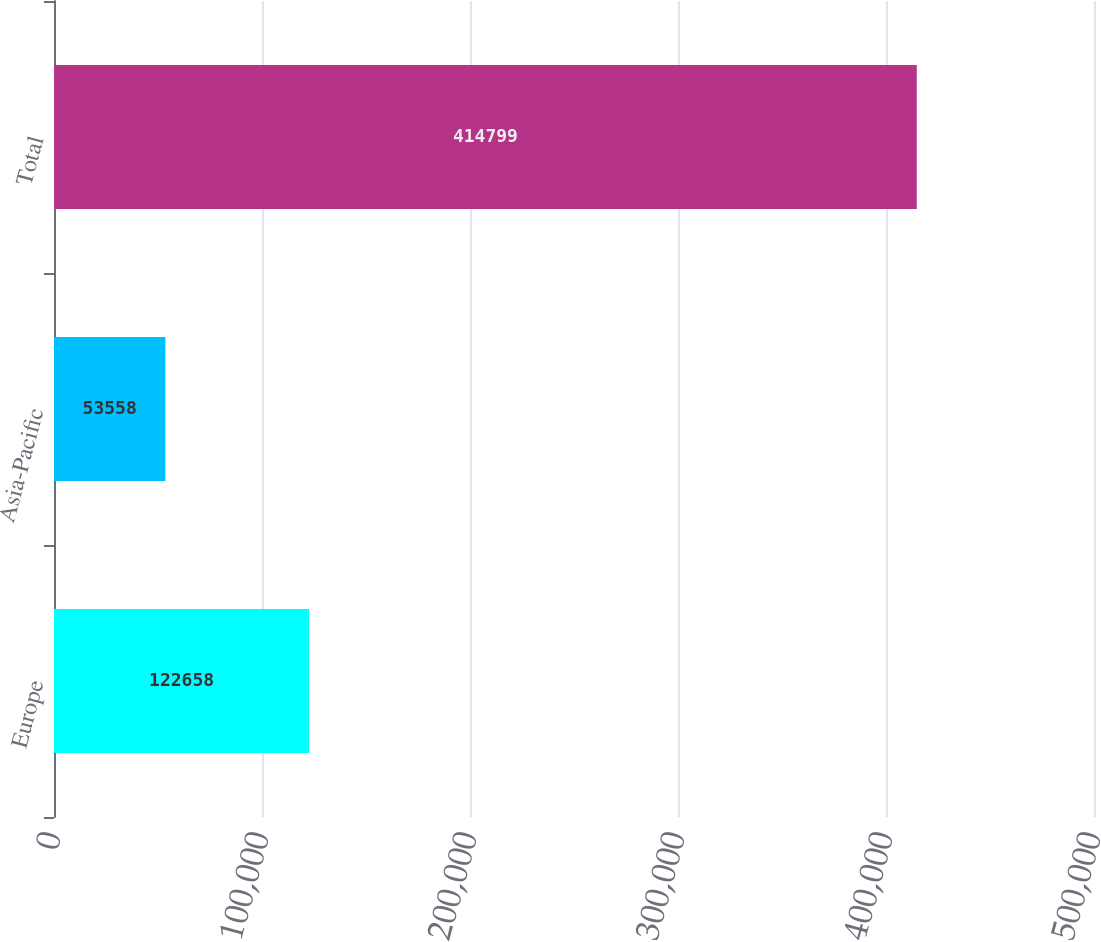Convert chart. <chart><loc_0><loc_0><loc_500><loc_500><bar_chart><fcel>Europe<fcel>Asia-Pacific<fcel>Total<nl><fcel>122658<fcel>53558<fcel>414799<nl></chart> 